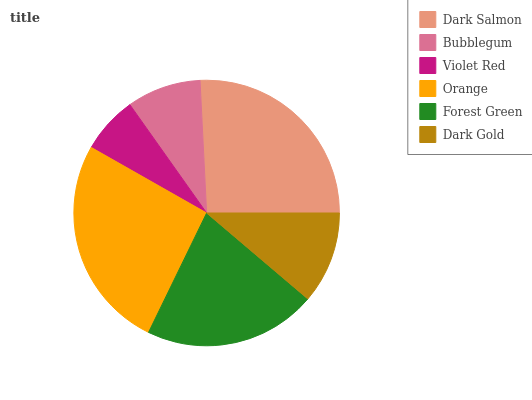Is Violet Red the minimum?
Answer yes or no. Yes. Is Orange the maximum?
Answer yes or no. Yes. Is Bubblegum the minimum?
Answer yes or no. No. Is Bubblegum the maximum?
Answer yes or no. No. Is Dark Salmon greater than Bubblegum?
Answer yes or no. Yes. Is Bubblegum less than Dark Salmon?
Answer yes or no. Yes. Is Bubblegum greater than Dark Salmon?
Answer yes or no. No. Is Dark Salmon less than Bubblegum?
Answer yes or no. No. Is Forest Green the high median?
Answer yes or no. Yes. Is Dark Gold the low median?
Answer yes or no. Yes. Is Bubblegum the high median?
Answer yes or no. No. Is Violet Red the low median?
Answer yes or no. No. 